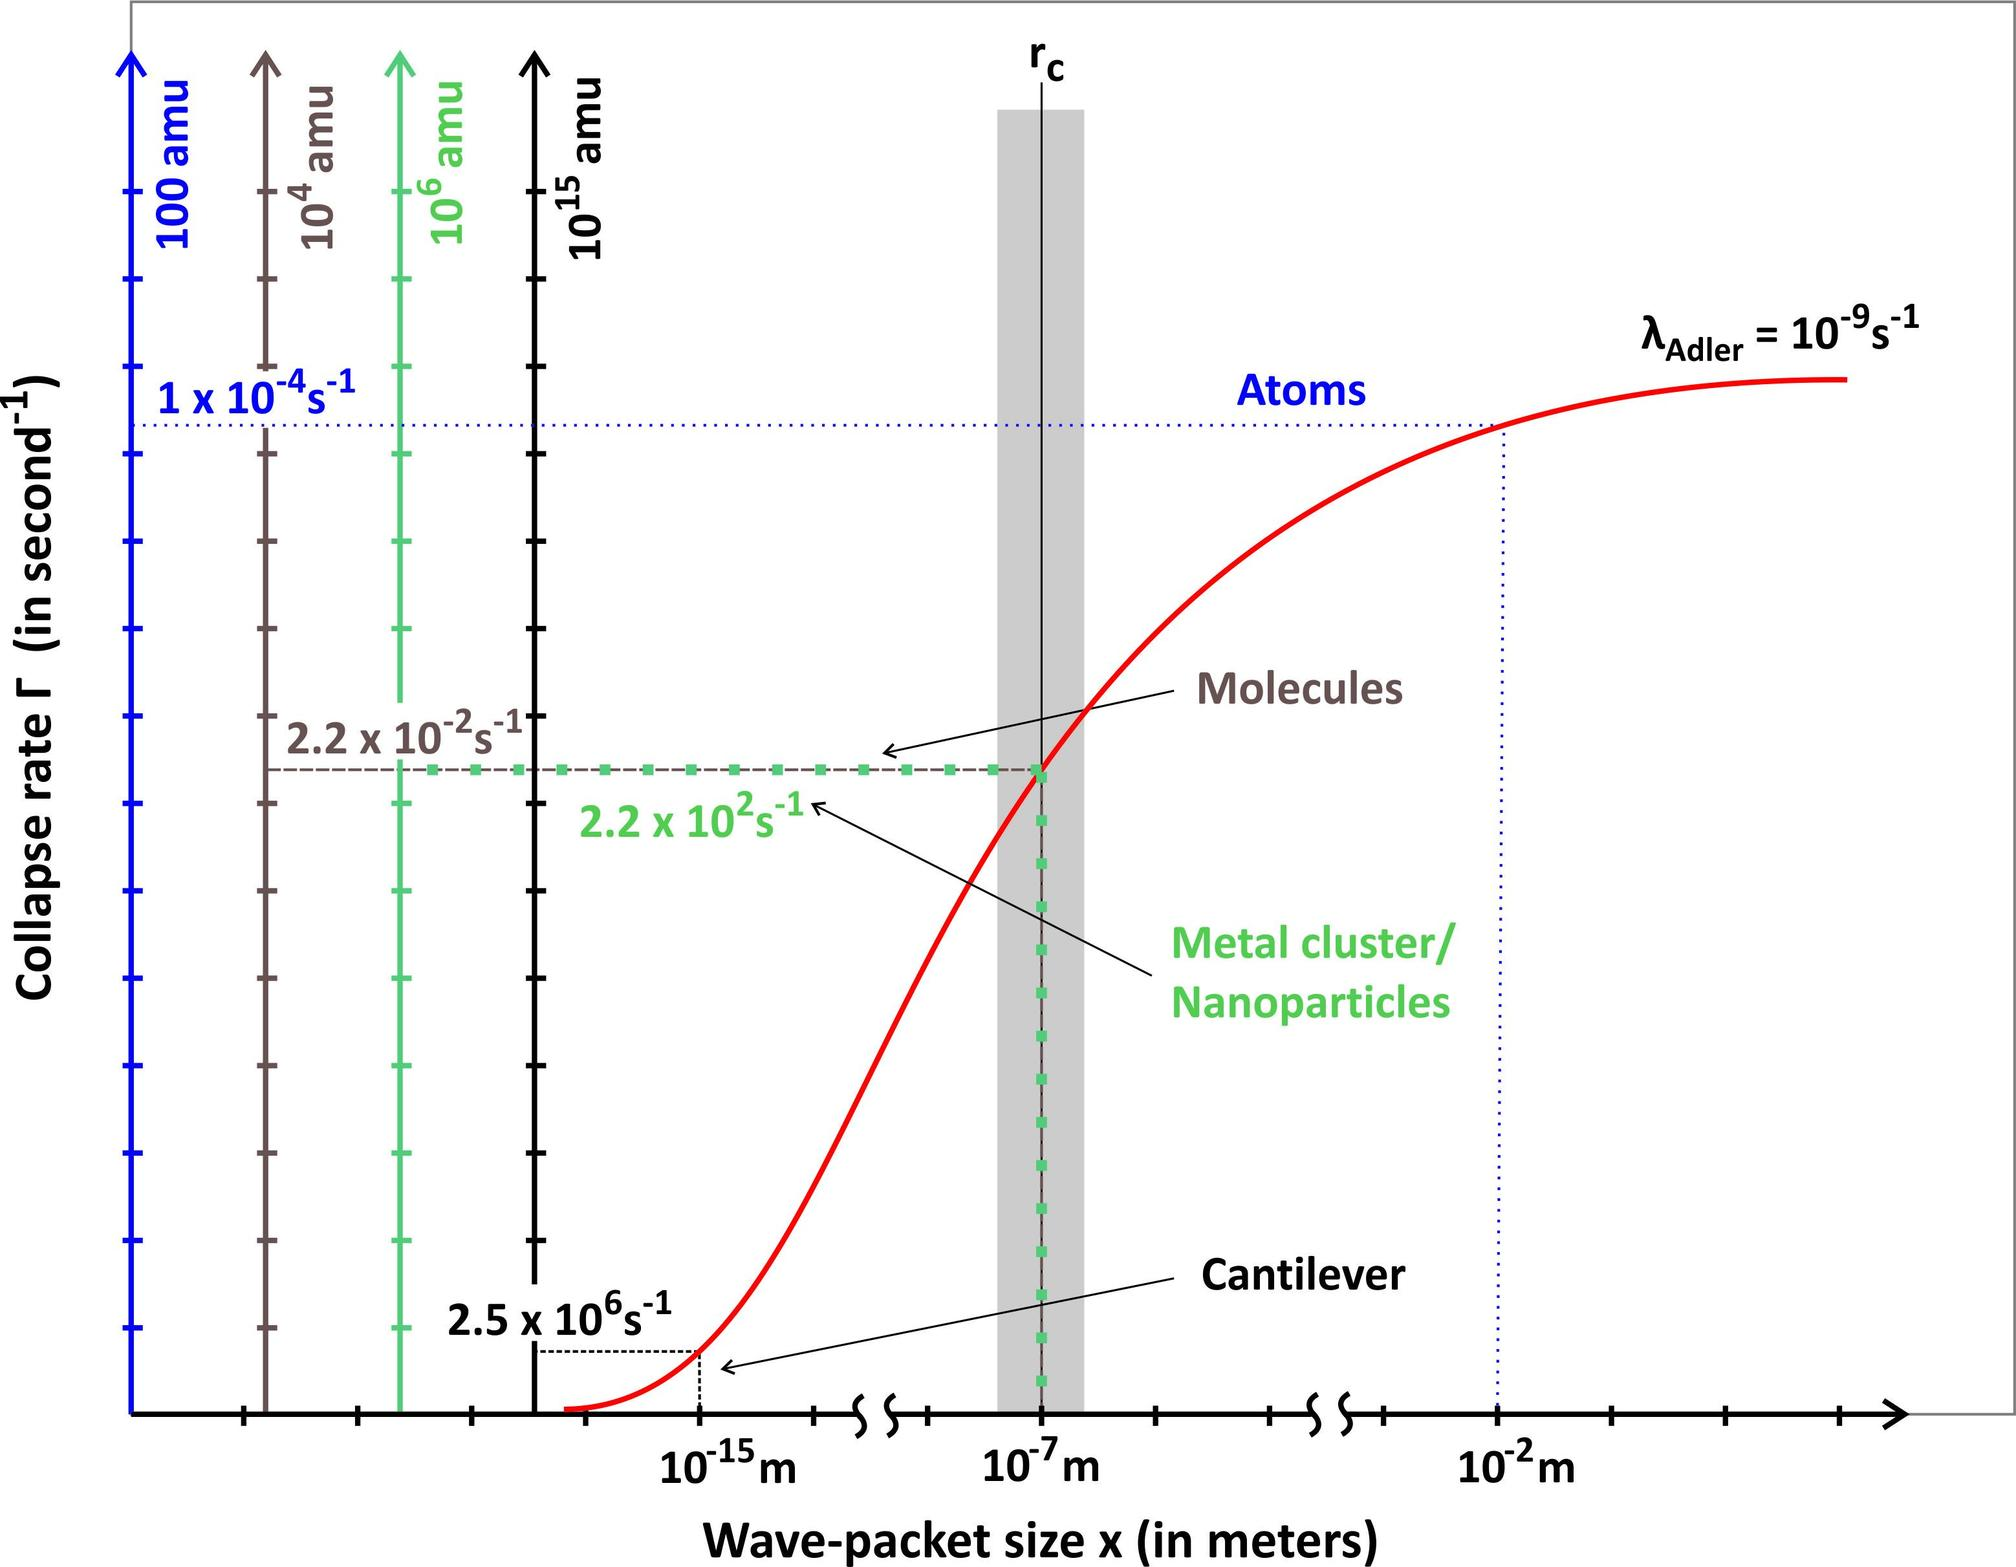What does the graph in the figure primarily illustrate? A. The relationship between temperature and gas solubility in liquids B. The effect of pressure on the boiling point of water C. The phase changes of water at different temperatures and pressures D. The comparison of thermal conductivity in various metals The graph you're looking at is a phase diagram, which is utilized to depict the different states (solid, liquid, and gas) of a substance under varying levels of temperature and pressure. The axis on the left represents the collapse rate in seconds inverse, indicating phase transitions over time due to environmental differences. The x-axis shows wave-packet size, which can be related to changes in the state of physical matter, reflecting when substances like water shift from one phase to another. Specifically, the lines in the diagram demarcate phase boundaries, and where they meet, critical points can be identified as where dramatic changes in phase occur. This analysis supports that the right answer is C, which corrects it to focus on phase changes at different temperatures and pressures in water. After this detailed look, it's clearer why this option is more accurate than the other choices. 